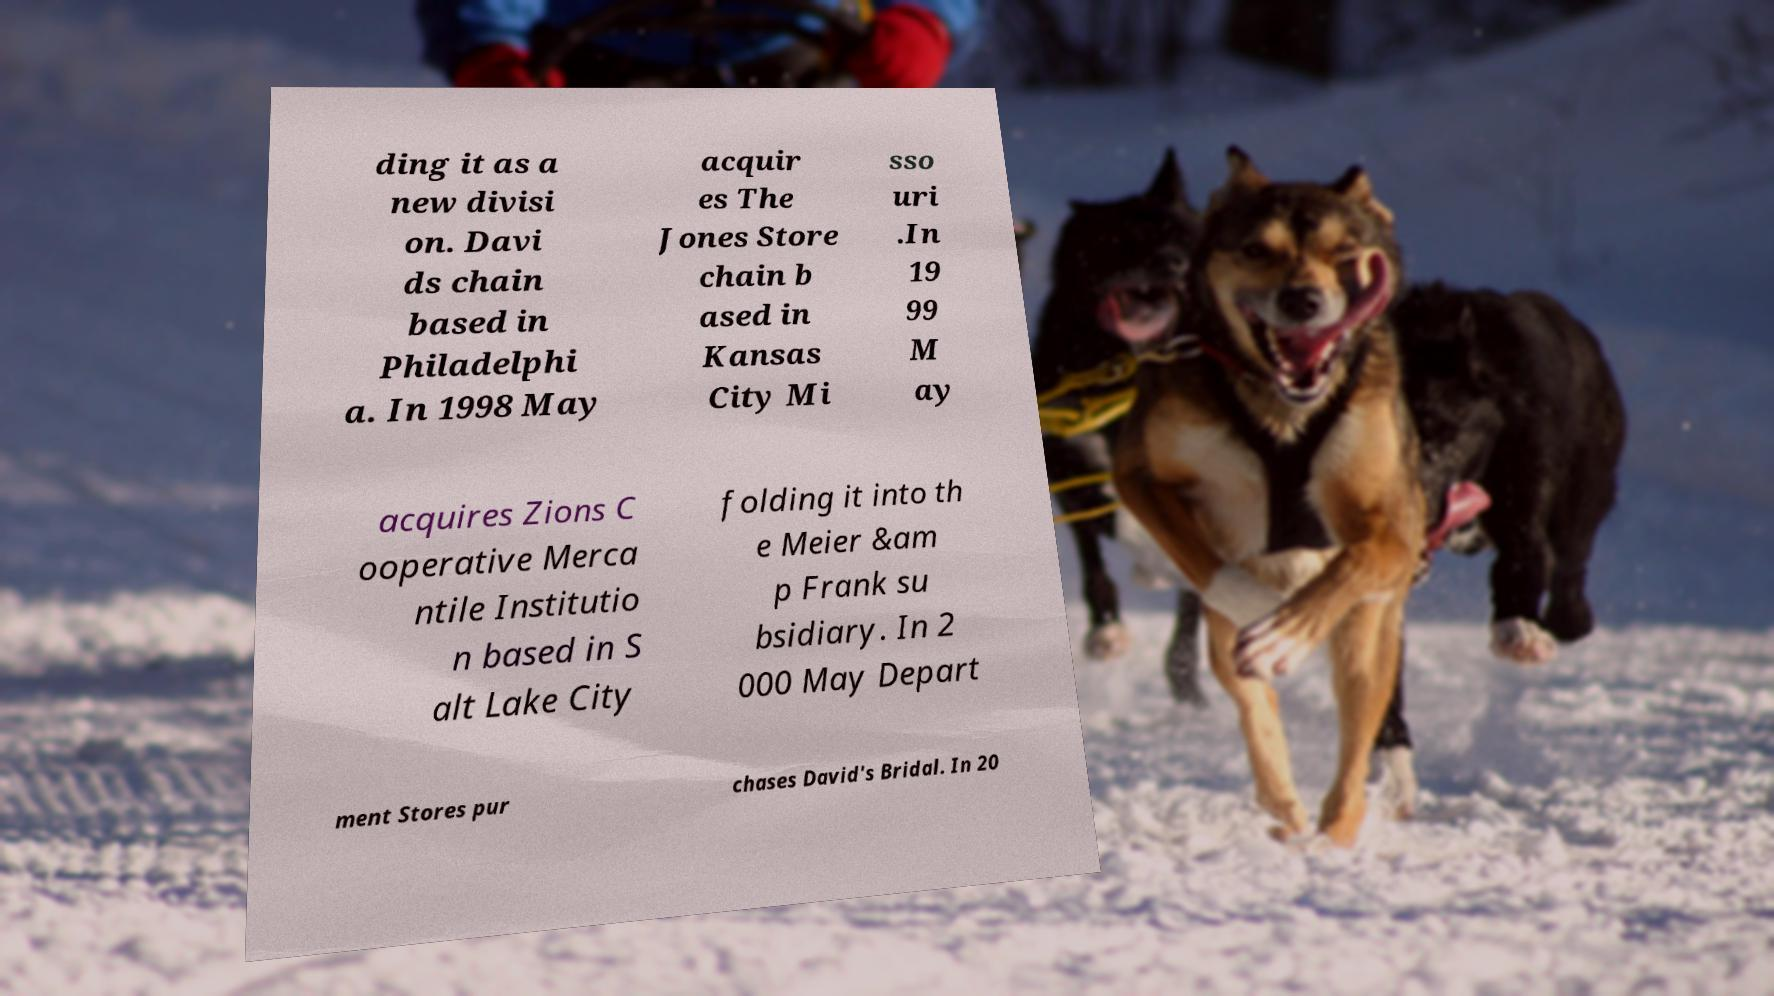Can you accurately transcribe the text from the provided image for me? ding it as a new divisi on. Davi ds chain based in Philadelphi a. In 1998 May acquir es The Jones Store chain b ased in Kansas City Mi sso uri .In 19 99 M ay acquires Zions C ooperative Merca ntile Institutio n based in S alt Lake City folding it into th e Meier &am p Frank su bsidiary. In 2 000 May Depart ment Stores pur chases David's Bridal. In 20 